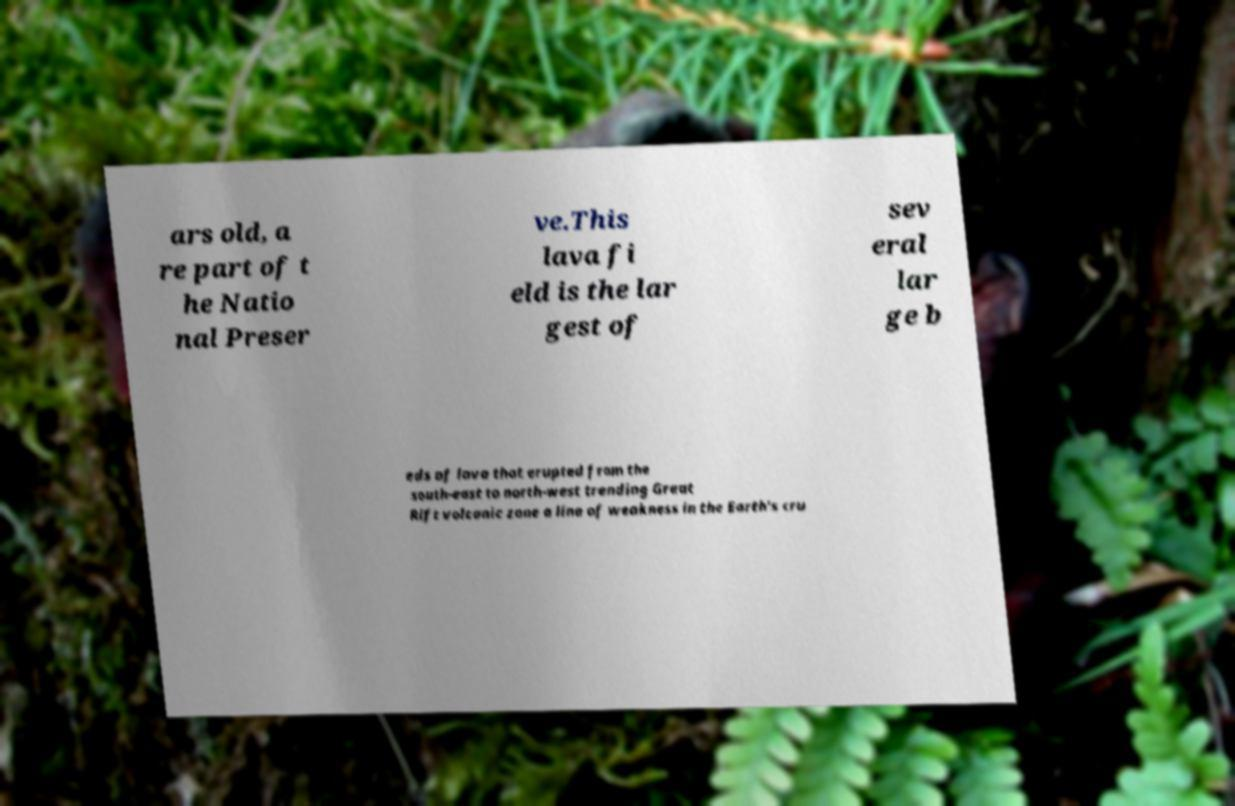I need the written content from this picture converted into text. Can you do that? ars old, a re part of t he Natio nal Preser ve.This lava fi eld is the lar gest of sev eral lar ge b eds of lava that erupted from the south-east to north-west trending Great Rift volcanic zone a line of weakness in the Earth's cru 